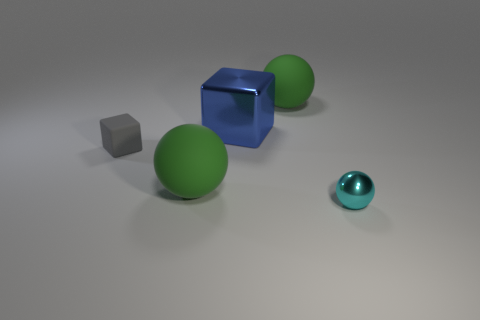The blue shiny thing that is the same shape as the gray matte object is what size?
Provide a short and direct response. Large. Is the number of big green objects that are to the left of the large blue metallic cube less than the number of small cyan things?
Give a very brief answer. No. There is a green matte thing left of the blue block; what size is it?
Your answer should be compact. Large. There is another small rubber object that is the same shape as the blue thing; what color is it?
Provide a short and direct response. Gray. What number of large matte objects are the same color as the large cube?
Keep it short and to the point. 0. Are there any other things that have the same shape as the cyan shiny thing?
Your answer should be very brief. Yes. There is a block to the right of the small thing behind the tiny cyan metal ball; is there a large metallic object on the right side of it?
Your answer should be compact. No. How many other small objects are the same material as the gray thing?
Offer a very short reply. 0. Does the green thing behind the gray cube have the same size as the blue object on the right side of the tiny gray matte cube?
Keep it short and to the point. Yes. What is the color of the rubber ball left of the large green matte ball that is behind the metallic thing that is behind the tiny metal sphere?
Ensure brevity in your answer.  Green. 